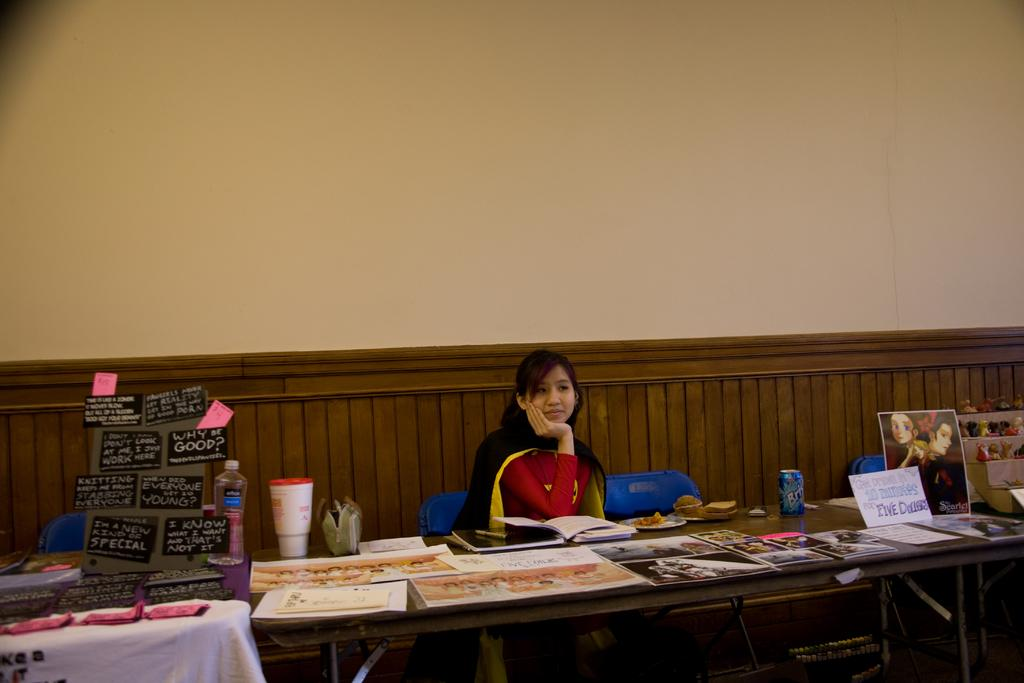What is the woman doing in the image? The woman is sitting on a chair in the image. Where is the woman located in the image? The woman is at a table in the image. What is on the table with the woman? There is a poster, a water bottle, and hoardings on the table in the image. What can be seen in the background of the image? There is a wall in the background of the image. How many frogs are jumping on the table in the image? There are no frogs present in the image; the table only contains a poster, a water bottle, and hoardings. What type of cakes are being served at the event in the image? There is no event or cakes depicted in the image; it only shows a woman sitting at a table with various objects. 